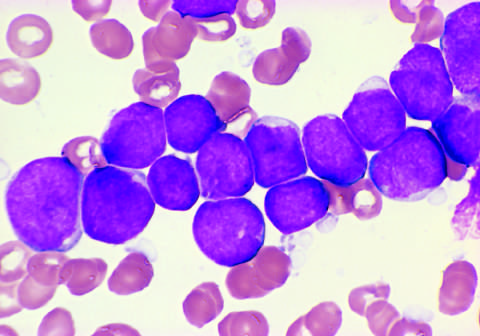does the absence of staining result for the all shown in the figure?
Answer the question using a single word or phrase. No 